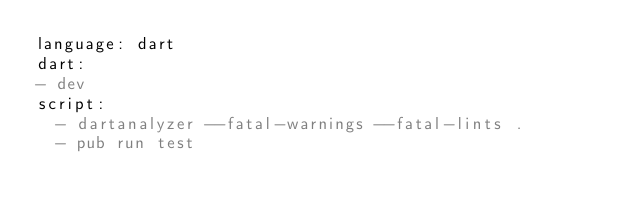Convert code to text. <code><loc_0><loc_0><loc_500><loc_500><_YAML_>language: dart
dart:
- dev
script:
  - dartanalyzer --fatal-warnings --fatal-lints .
  - pub run test</code> 